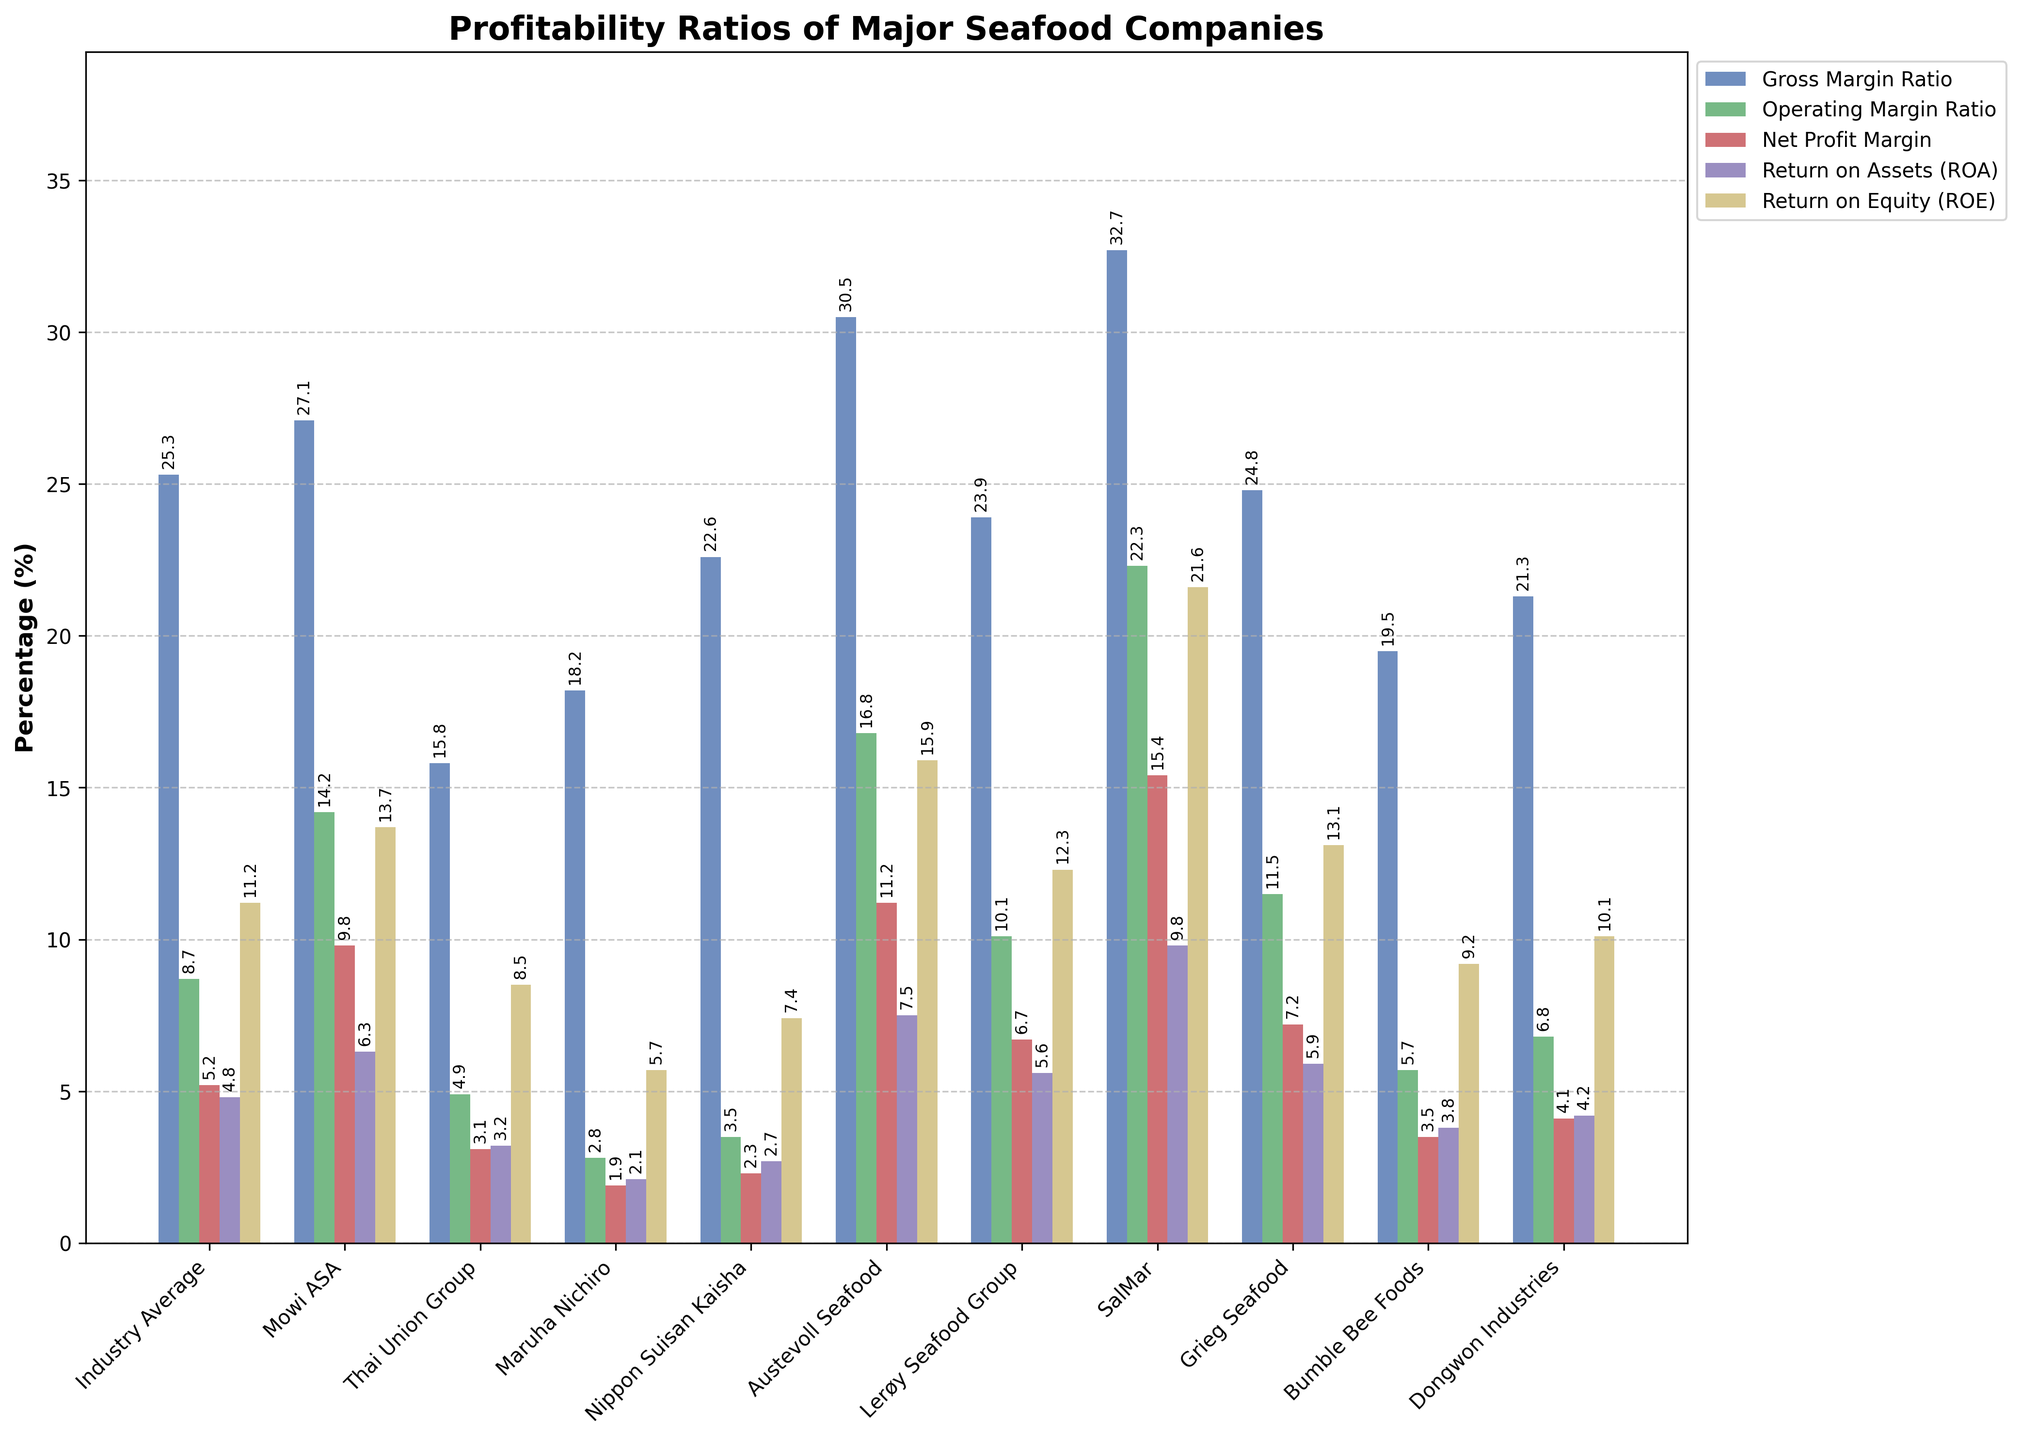Which company has the highest Gross Margin Ratio? By visually inspecting the height of the bars corresponding to the Gross Margin Ratio for each company, SalMar has the tallest bar, indicating the highest Gross Margin Ratio.
Answer: SalMar Which company performs better than the industry average in all profitability ratios? By comparing the height of the bars for each company to the industry average in all five profitability ratios, only Mowi ASA and Austevoll Seafood show bars higher than the industry average in all categories.
Answer: Mowi ASA and Austevoll Seafood What is the difference in Net Profit Margin between SalMar and Thai Union Group? The bar for SalMar’s Net Profit Margin is at 15.4%, and Thai Union Group’s Net Profit Margin is at 3.1%. Subtracting these values gives the difference: 15.4% - 3.1% = 12.3%.
Answer: 12.3% Which company has a higher Return on Equity (ROE) than the industry average but a lower Operating Margin Ratio? The industry average ROE is 11.2%, and the companies with higher ROEs are Mowi ASA, Austevoll Seafood, Lerøy Seafood Group, SalMar, and Grieg Seafood. Among these, Lerøy Seafood Group has an Operating Margin Ratio of 10.1%, which is higher than the industry average of 8.7%. The company fitting both criteria is Dongwon Industries, as it has an ROE of 10.1%, higher than the industry average but a lower Operating Margin Ratio of 6.8%.
Answer: Dongwon Industries Compare the Gross Margin Ratio of Mowi ASA and Lerøy Seafood Group. Which one is higher and by how much? The Gross Margin Ratio for Mowi ASA is 27.1%, and for Lerøy Seafood Group, it is 23.9%. The difference is calculated as 27.1% - 23.9% = 3.2%. Therefore, Mowi ASA has a higher Gross Margin Ratio by 3.2%.
Answer: Mowi ASA, 3.2% Which profitability ratio shows the most significant variation across all companies? Visually inspecting the lengths of the bars for each profitability ratio, the Return on Equity (ROE) bars show the most considerable variation, ranging from Maruha Nichiro's 5.7% to SalMar’s 21.6%.
Answer: Return on Equity (ROE) Does Grieg Seafood outperform the industry average in Operating Margin Ratio and Return on Assets (ROA)? Comparing the bar lengths for Grieg Seafood and the industry average, Grieg Seafood has an Operating Margin Ratio of 11.5% and an ROA of 5.9%. Both are higher than the industry averages of 8.7% and 4.8%, respectively.
Answer: Yes How much higher is Austevoll Seafood’s Return on Assets (ROA) compared to Nippon Suisan Kaisha? Austevoll Seafood’s ROA is 7.5%, and Nippon Suisan Kaisha’s ROA is 2.7%. The difference is 7.5% - 2.7% = 4.8%.
Answer: 4.8% Which company has the lowest Net Profit Margin, and what is the value? By looking at the bars corresponding to Net Profit Margin, Maruha Nichiro has the shortest bar, indicating the lowest Net Profit Margin of 1.9%.
Answer: Maruha Nichiro, 1.9% What is the combined percentage of Operating Margin Ratio for Mowi ASA and SalMar? The Operating Margin Ratio for Mowi ASA is 14.2%, and for SalMar, it is 22.3%. Adding these values gives 14.2% + 22.3% = 36.5%.
Answer: 36.5% 